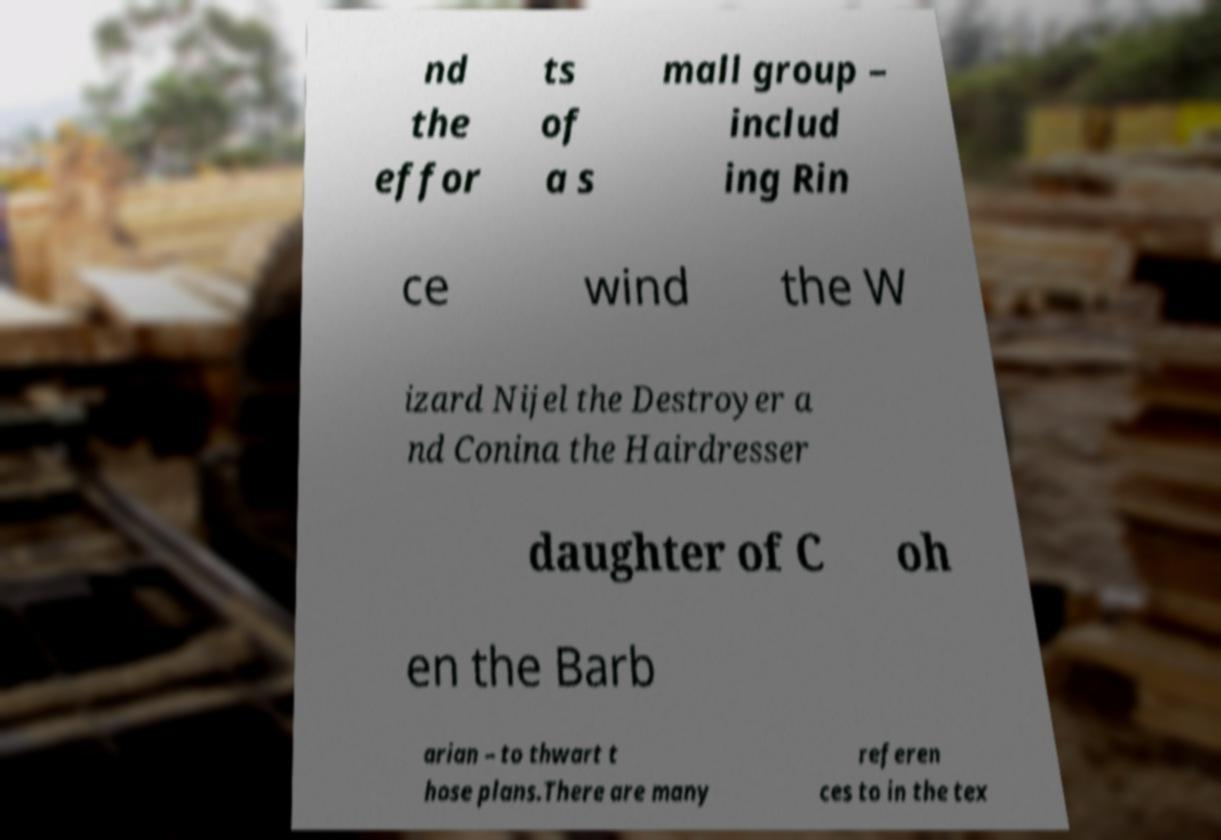There's text embedded in this image that I need extracted. Can you transcribe it verbatim? nd the effor ts of a s mall group – includ ing Rin ce wind the W izard Nijel the Destroyer a nd Conina the Hairdresser daughter of C oh en the Barb arian – to thwart t hose plans.There are many referen ces to in the tex 